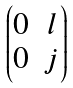<formula> <loc_0><loc_0><loc_500><loc_500>\begin{pmatrix} 0 & l \\ 0 & j \end{pmatrix}</formula> 